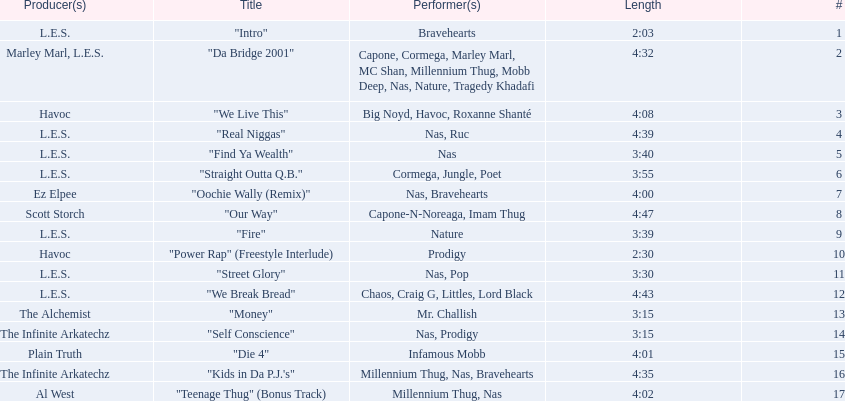What are all the song titles? "Intro", "Da Bridge 2001", "We Live This", "Real Niggas", "Find Ya Wealth", "Straight Outta Q.B.", "Oochie Wally (Remix)", "Our Way", "Fire", "Power Rap" (Freestyle Interlude), "Street Glory", "We Break Bread", "Money", "Self Conscience", "Die 4", "Kids in Da P.J.'s", "Teenage Thug" (Bonus Track). Who produced all these songs? L.E.S., Marley Marl, L.E.S., Ez Elpee, Scott Storch, Havoc, The Alchemist, The Infinite Arkatechz, Plain Truth, Al West. Of the producers, who produced the shortest song? L.E.S. How short was this producer's song? 2:03. 